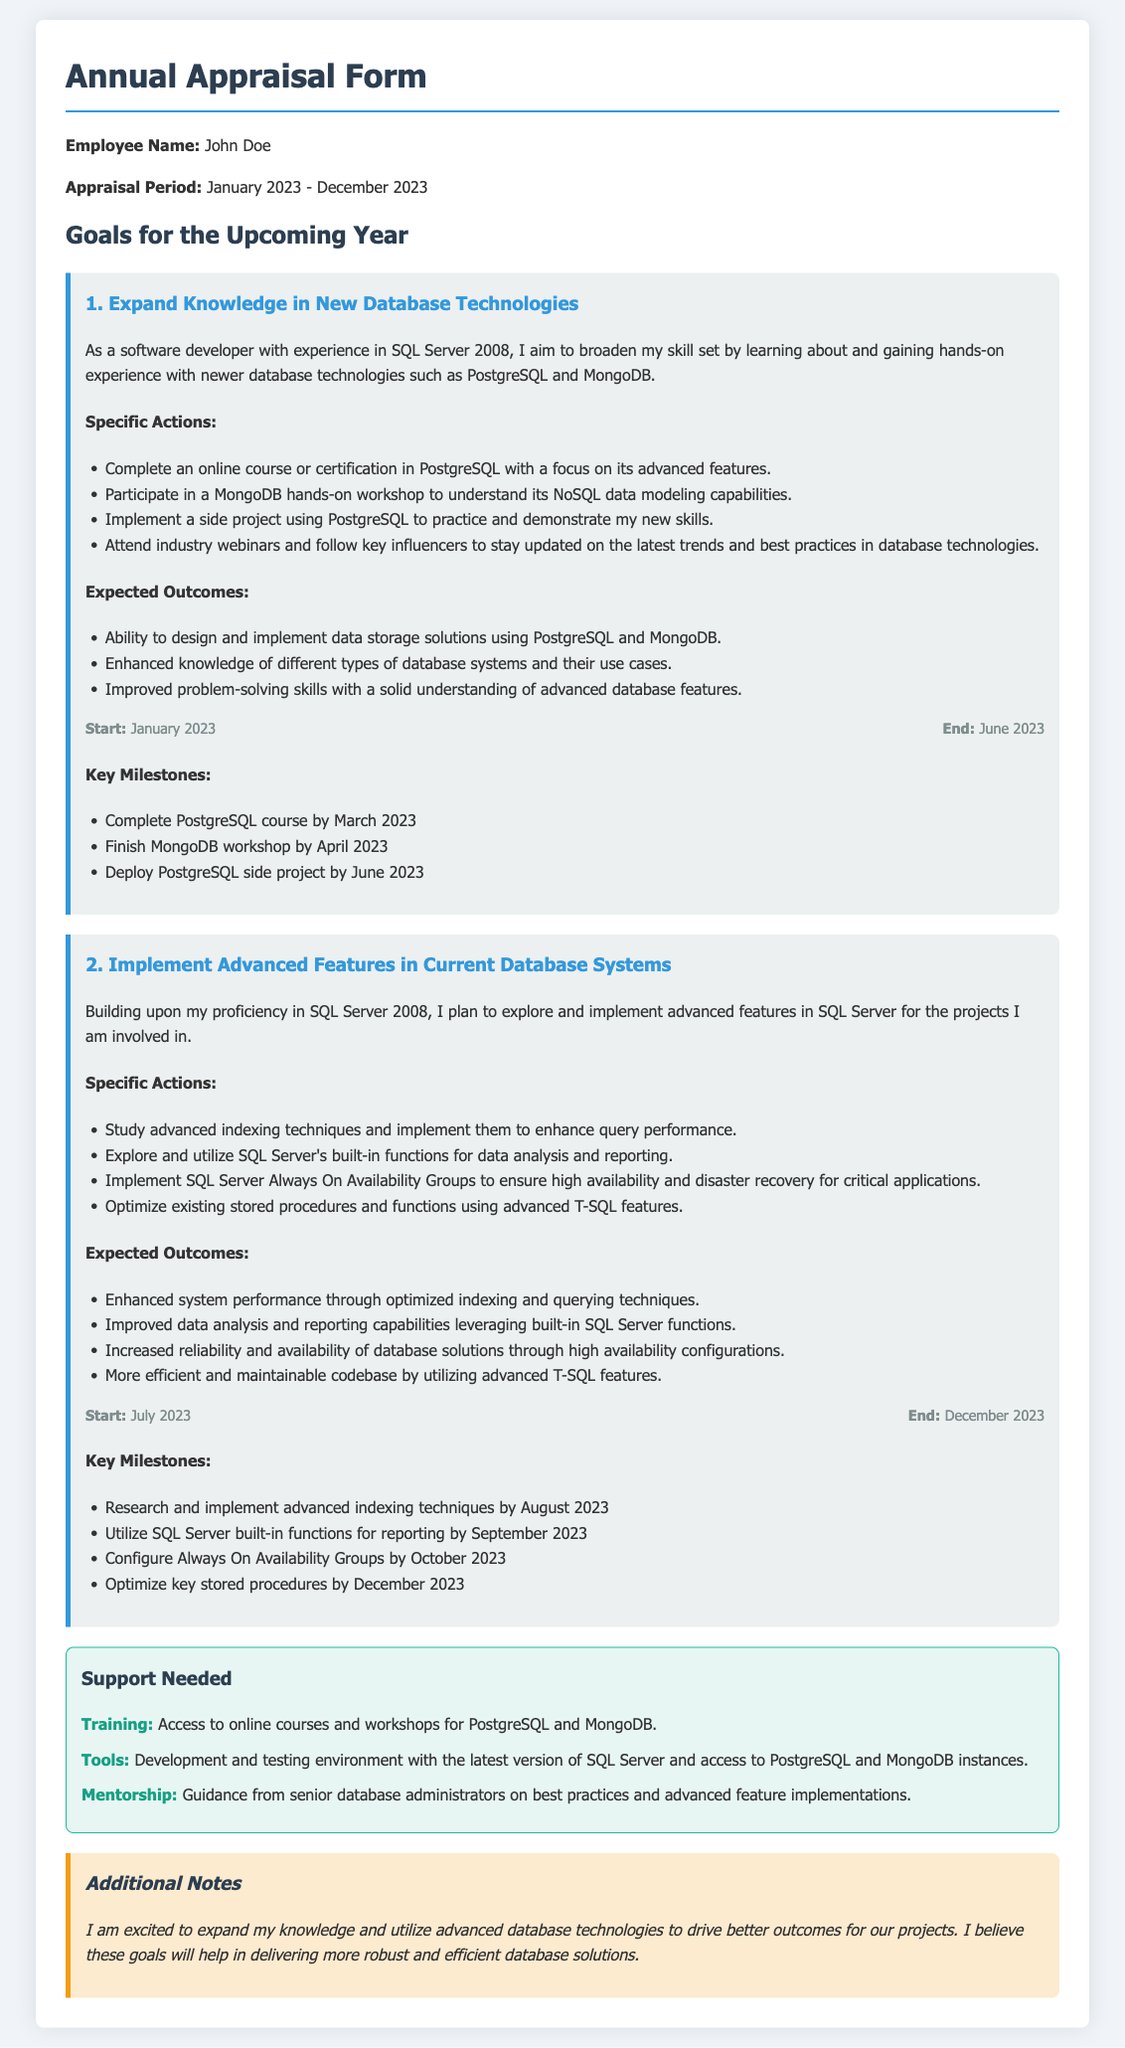What is the employee's name? The employee's name is mentioned at the beginning of the document.
Answer: John Doe What is the appraisal period? The appraisal period is specified in the document.
Answer: January 2023 - December 2023 What is the first goal listed? The first goal is highlighted as one of the main objectives in the document.
Answer: Expand Knowledge in New Database Technologies When will the PostgreSQL course be completed? The completion date for the PostgreSQL course is listed in the key milestones section.
Answer: March 2023 What is the expected outcome of implementing SQL Server's built-in functions? The expected outcome is stated under the expected outcomes for the second goal.
Answer: Improved data analysis and reporting capabilities What type of mentorship is needed? The type of mentorship required is specified in the support needed section.
Answer: Guidance from senior database administrators What is the end date for the second goal? The end date is provided in the timeline for the second goal.
Answer: December 2023 What specific support is needed for training? The specific training support required is mentioned in the support needed section.
Answer: Access to online courses and workshops for PostgreSQL and MongoDB How many milestones are listed for the first goal? The number of milestones can be counted from the listed items in the key milestones section for the first goal.
Answer: Four 